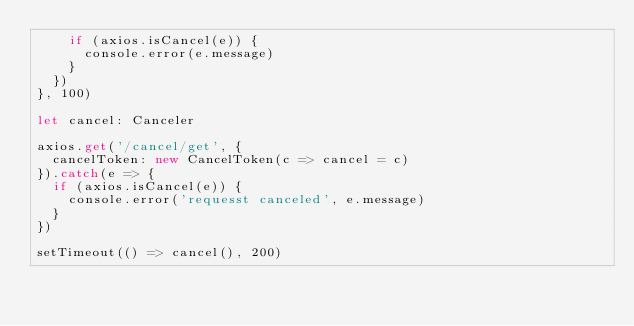<code> <loc_0><loc_0><loc_500><loc_500><_TypeScript_>    if (axios.isCancel(e)) {
      console.error(e.message)
    }
  })
}, 100)

let cancel: Canceler

axios.get('/cancel/get', {
  cancelToken: new CancelToken(c => cancel = c)
}).catch(e => {
  if (axios.isCancel(e)) {
    console.error('requesst canceled', e.message)
  }
})

setTimeout(() => cancel(), 200)
</code> 